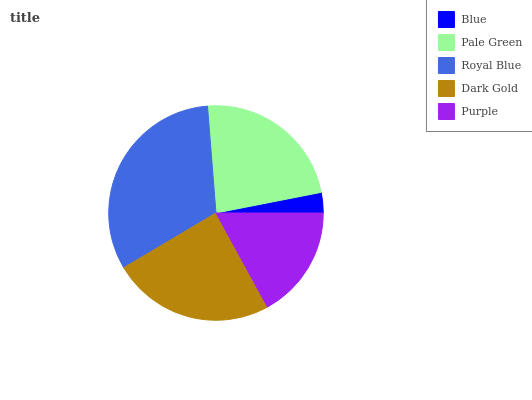Is Blue the minimum?
Answer yes or no. Yes. Is Royal Blue the maximum?
Answer yes or no. Yes. Is Pale Green the minimum?
Answer yes or no. No. Is Pale Green the maximum?
Answer yes or no. No. Is Pale Green greater than Blue?
Answer yes or no. Yes. Is Blue less than Pale Green?
Answer yes or no. Yes. Is Blue greater than Pale Green?
Answer yes or no. No. Is Pale Green less than Blue?
Answer yes or no. No. Is Pale Green the high median?
Answer yes or no. Yes. Is Pale Green the low median?
Answer yes or no. Yes. Is Blue the high median?
Answer yes or no. No. Is Blue the low median?
Answer yes or no. No. 